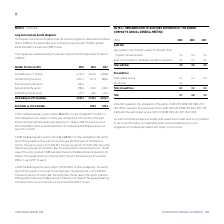According to Torm's financial document, What was the remuneration to the auditor in 2019? According to the financial document, USD 0.7m. The relevant text states: "C regulations, the remuneration of the auditor of USD 0.7m (2018: USD 0.8m, 2017: USD 1.0m) is required to be presented as follows: Audit USD 0.6m (2018: USD..." Also, What was the amount of total audit fees in 2019? According to the financial document, USD 0.6m. The relevant text states: "0m) is required to be presented as follows: Audit USD 0.6m (2018: USD 0.6m, 2017: USD 0.6m) and other audit-related services USD 0.1m (2018: USD 0.2m, 2017: U 0m) is required to be presented as follow..." Also, What are the types of audit fees in the table? The document shows two values: Fees payable to the Company's auditor for the audit of the Company's annual accounts and Audit of the Company's subsidiaries pursuant to legislation. From the document: "Audit of the Company's subsidiaries pursuant to legislation 0.2 0.2 0.2..." Additionally, In which year was the total remuneration to the auditor the largest? According to the financial document, 2017. The relevant text states: "USDm 2019 2018 2017..." Also, can you calculate: What was the change in the the total remuneration to the auditor in 2019 from 2018? Based on the calculation: 0.7-0.8, the result is -0.1 (in millions). This is based on the information: "Total 0.7 0.8 1.0 Total 0.7 0.8 1.0..." The key data points involved are: 0.7, 0.8. Also, can you calculate: What was the percentage change in the the total remuneration to the auditor in 2019 from 2018? To answer this question, I need to perform calculations using the financial data. The calculation is: (0.7-0.8)/0.8, which equals -12.5 (percentage). This is based on the information: "Total 0.7 0.8 1.0 Total 0.7 0.8 1.0..." The key data points involved are: 0.7, 0.8. 